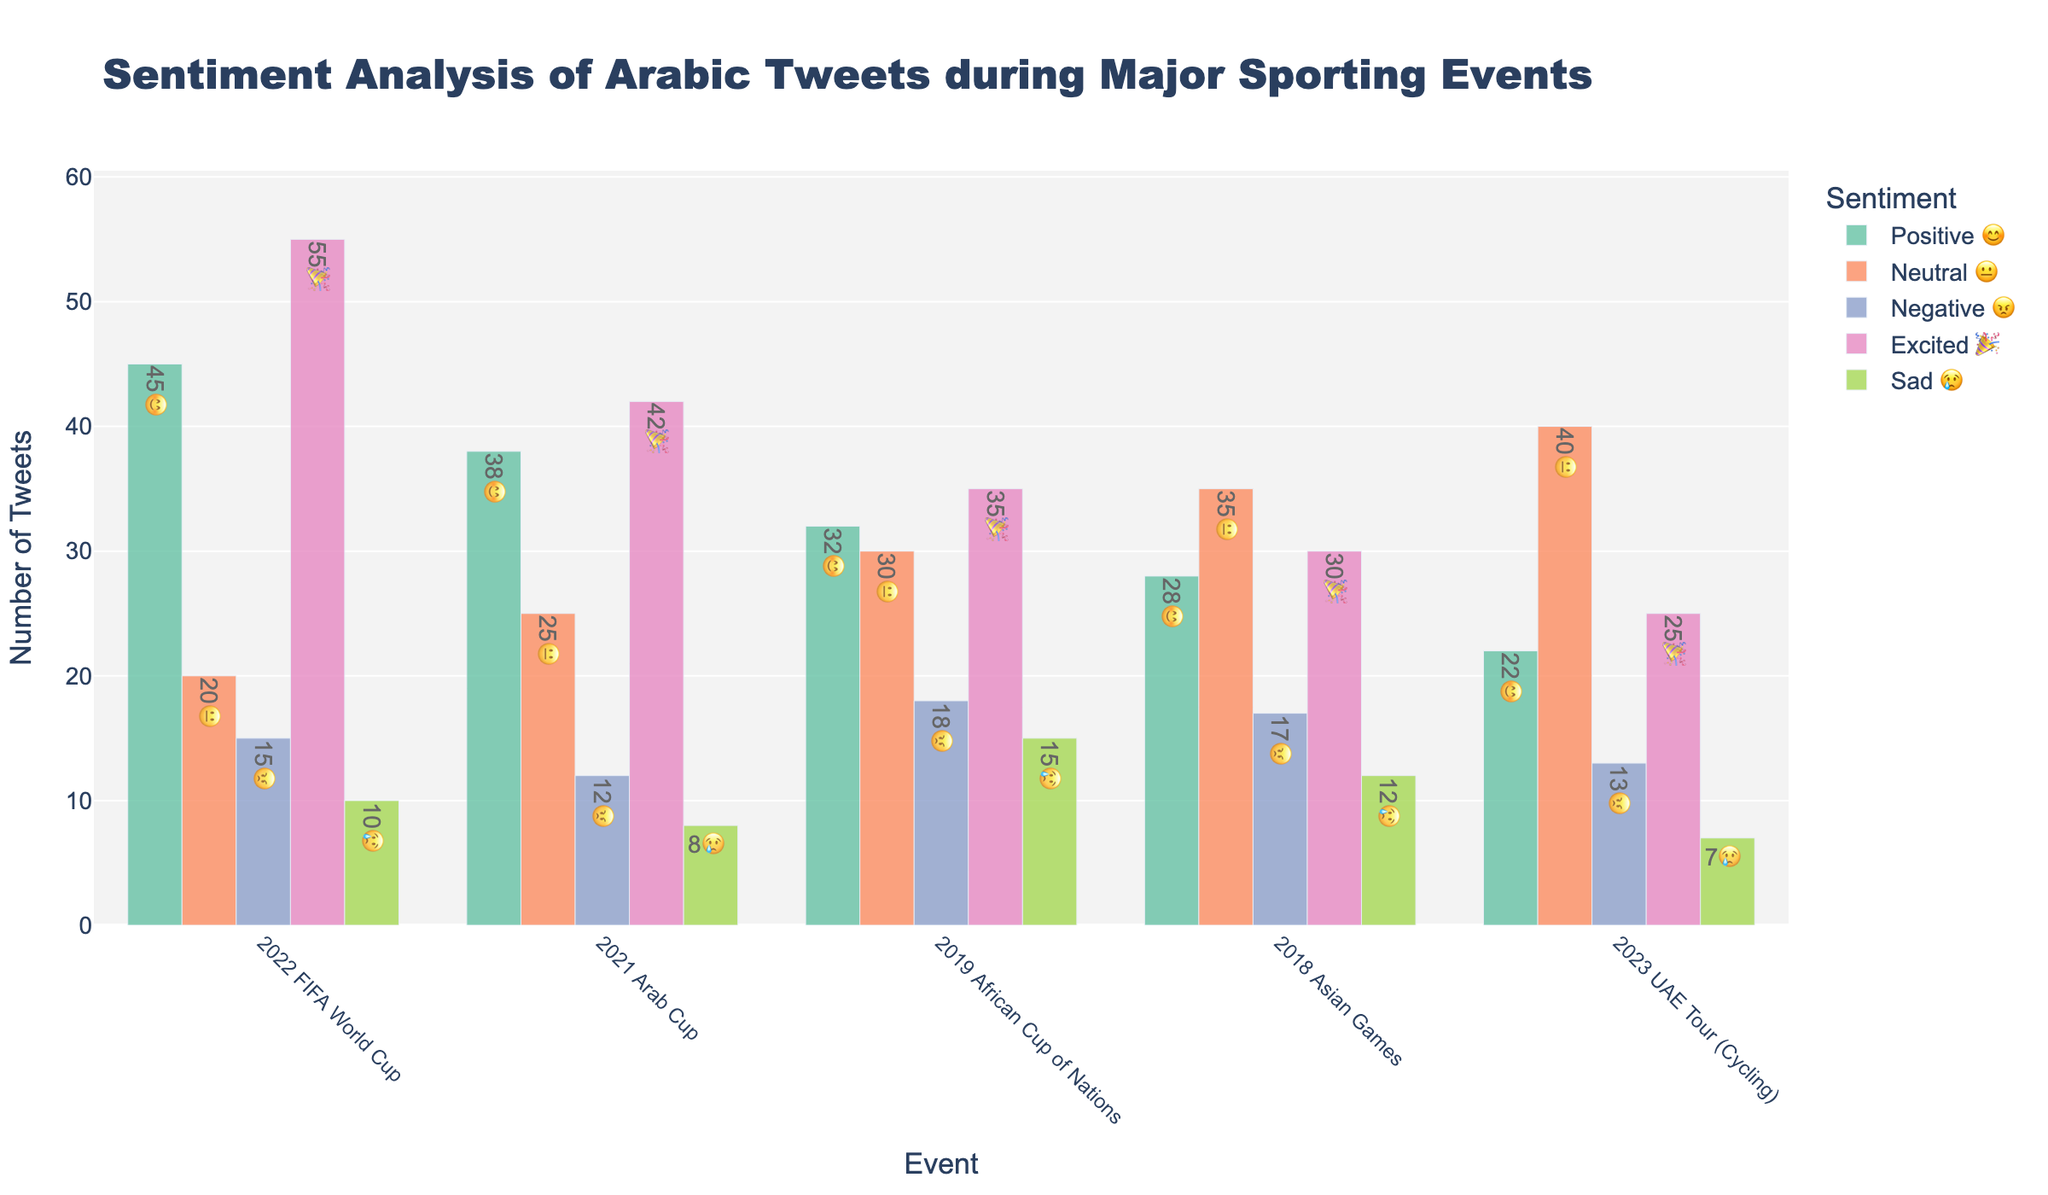How many tweets were classified as Neutral 😐 during the 2023 UAE Tour (Cycling)? The color representing Neutral 😐 tweets is identified, then the corresponding bar height for the 2023 UAE Tour (Cycling) event is read.
Answer: 40 Which event had the highest number of Positive 😊 tweets? By examining the bars for Positive 😊 tweets in each event, the 2022 FIFA World Cup has the tallest bar among all events.
Answer: 2022 FIFA World Cup What is the total number of Negative 😠 tweets across all events? Summing the heights of the Negative 😠 bars in all events: 15 (FIFA 2022) + 12 (Arab Cup 2021) + 18 (African Cup 2019) + 17 (Asian Games 2018) + 13 (UAE Tour 2023) = 75.
Answer: 75 Between which two events is the biggest difference in the number of Excited 🎉 tweets, and what is that difference? Finding the minimum and maximum bars for Excited 🎉 tweets: max is 55 (FIFA 2022) and min is 25 (UAE Tour 2023). The difference is 55 - 25 = 30.
Answer: FIFA 2022 vs UAE Tour 2023, 30 Which event had the smallest number of Sad 😢 tweets, and how many were there? By examining the bars for Sad 😢 tweets, the event with the lowest bar height is the 2023 UAE Tour (Cycling) with 7 tweets.
Answer: 2023 UAE Tour (Cycling), 7 How does the number of Neutral 😐 tweets during the 2018 Asian Games compare to the number of Excited 🎉 tweets in the same event? Compare the height of Neutral 😐 (35) to Excited 🎉 (30) in the 2018 Asian Games: 35 > 30.
Answer: Neutral 😐 > Excited 🎉 What is the average number of Positive 😊 tweets across all events? Summing the Positive 😊 tweets: 45 + 38 + 32 + 28 + 22 = 165. Dividing by 5 events: 165 / 5 = 33.
Answer: 33 In which event was the number of Excited 🎉 tweets closest to 40? Examining the heights close to 40 for Excited 🎉 tweets, the 2021 Arab Cup has 42 Tweets, which is the closest.
Answer: 2021 Arab Cup 